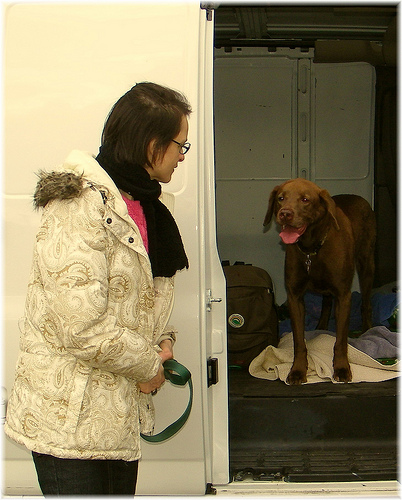<image>
Is the dog next to the woman? Yes. The dog is positioned adjacent to the woman, located nearby in the same general area. 